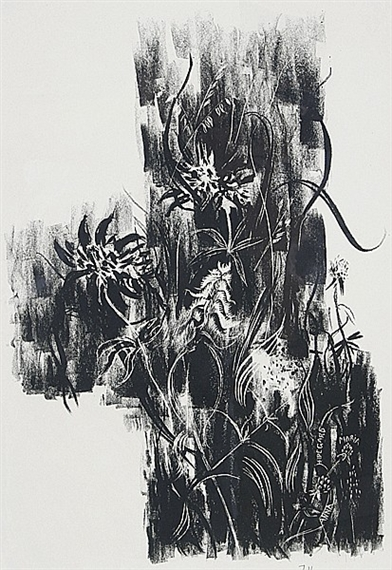What is this photo about? The image you've shared is an intriguing piece of abstract art. It presents a monochromatic composition, starkly contrasting the black background with intricate white lines and shapes. The style appears to be expressionist, emphasizing emotional and subjective interpretations over realistic representations. 

The white lines and shapes in the artwork are fluid and organic, almost resembling a dynamic, living entity. They weave through the space with a sense of depth and texture, inviting the viewer to follow their intricate paths. These patterns are characteristic of the printmaking process, highlighting the artist's skill and creativity. 

Despite its abstract nature, the image conveys a sense of movement and rhythmic flow, as if the lines and shapes are constantly evolving. This piece is a powerful example of abstract expressionism, showcasing the beauty and infinite possibilities of this artistic genre. 